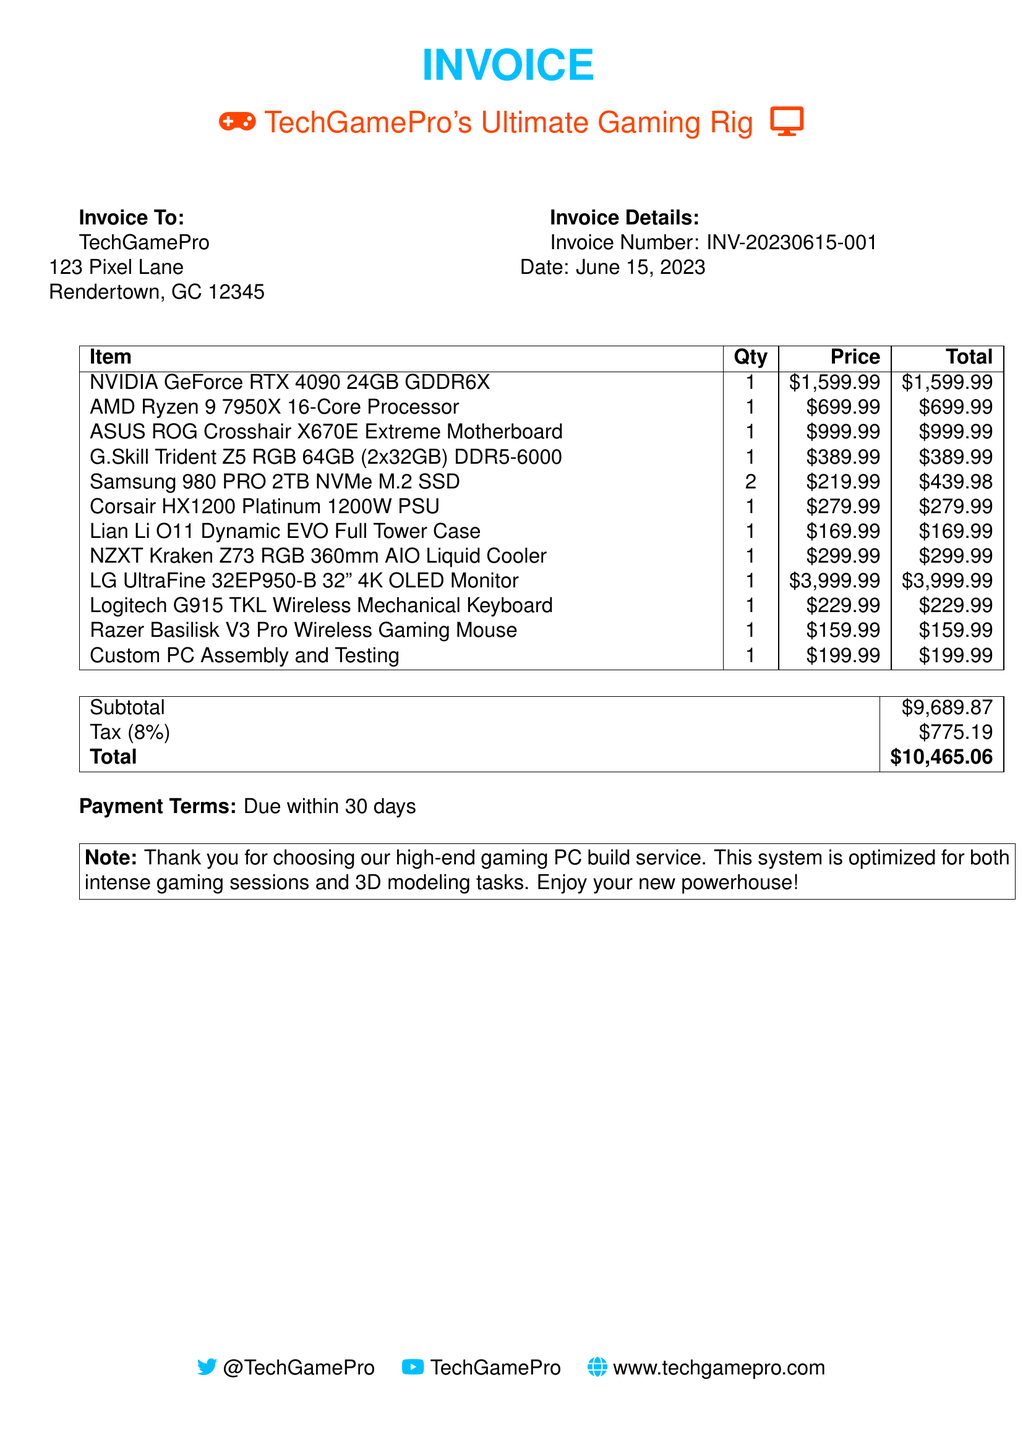What is the invoice number? The invoice number is clearly stated in the invoice details section.
Answer: INV-20230615-001 What is the total amount due? The total amount due is prominently displayed at the bottom of the invoice.
Answer: $10,465.06 How many SSDs were purchased? The document lists the quantity for the Samsung 980 PRO NVMe SSD.
Answer: 2 What is the price of the NVIDIA GeForce RTX 4090? The price of this GPU is provided in the itemized list of components.
Answer: $1,599.99 What is the subtotal before tax? The subtotal is detailed in the summary table of the invoice.
Answer: $9,689.87 What is the tax percentage? The tax percentage is mentioned in the summary of the invoice.
Answer: 8% Why was the custom PC assembly included in the invoice? The service of custom PC assembly is necessary for the build and is specified as a line item.
Answer: Custom PC Assembly and Testing What type of case is included in the build? The type of case used is listed in the itemized components section of the invoice.
Answer: Lian Li O11 Dynamic EVO Full Tower Case What payment terms are stated in the invoice? The terms for payment are specified towards the end of the document.
Answer: Due within 30 days 